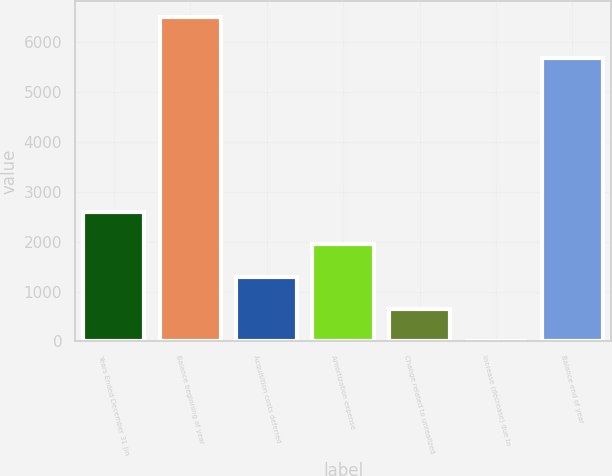<chart> <loc_0><loc_0><loc_500><loc_500><bar_chart><fcel>Years Ended December 31 (in<fcel>Balance beginning of year<fcel>Acquisition costs deferred<fcel>Amortization expense<fcel>Change related to unrealized<fcel>Increase (decrease) due to<fcel>Balance end of year<nl><fcel>2602<fcel>6502<fcel>1302<fcel>1952<fcel>652<fcel>2<fcel>5672<nl></chart> 